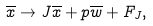Convert formula to latex. <formula><loc_0><loc_0><loc_500><loc_500>\overline { x } \to J \overline { x } + p \overline { w } + F _ { J } ,</formula> 